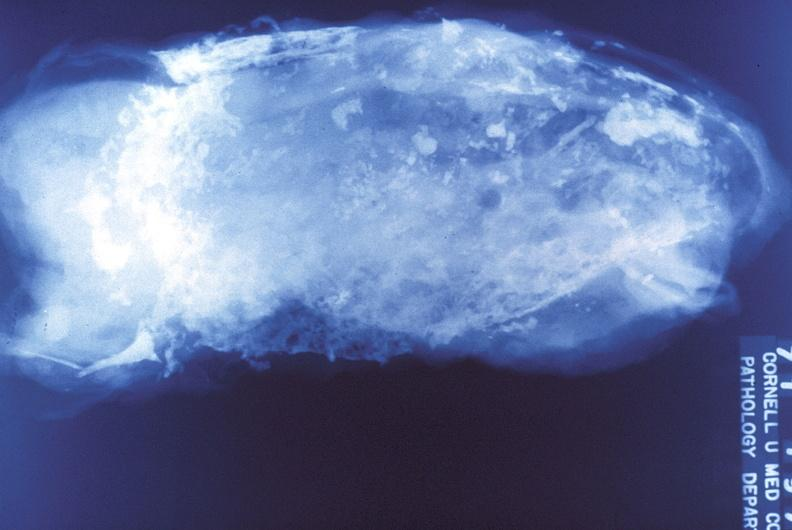does basilar skull fracture show tuberculosis, empyema?
Answer the question using a single word or phrase. No 